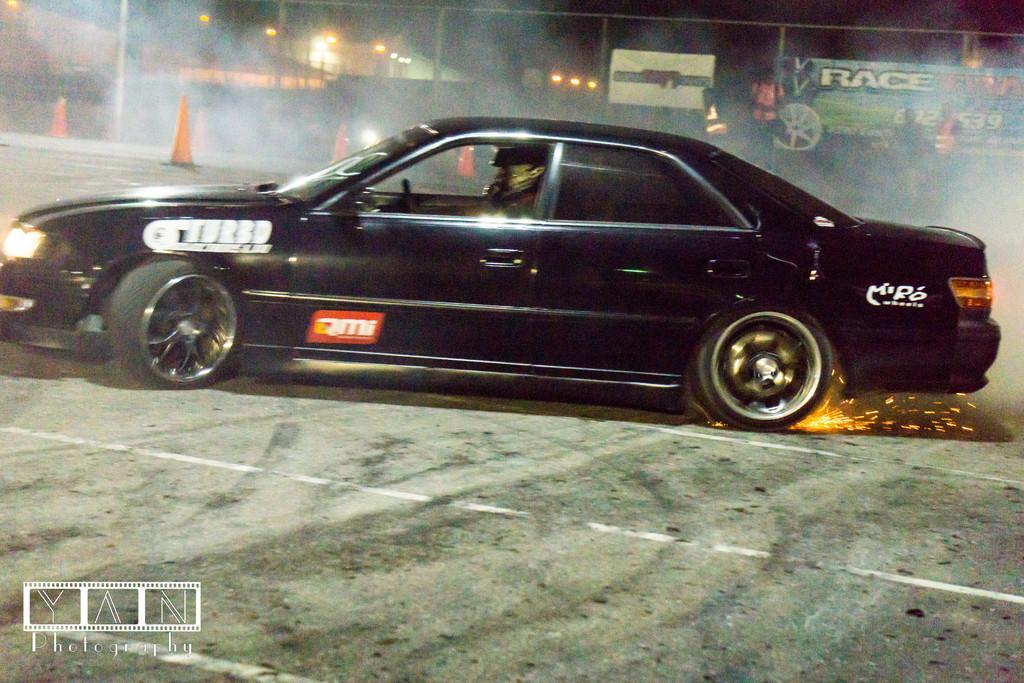In one or two sentences, can you explain what this image depicts? In this image in the center there is one car, and in that car there is one person who is sitting and driving. In the background there are some poles, lights, houses and some barricades and there are some people who are standing. At the bottom there is a road. 